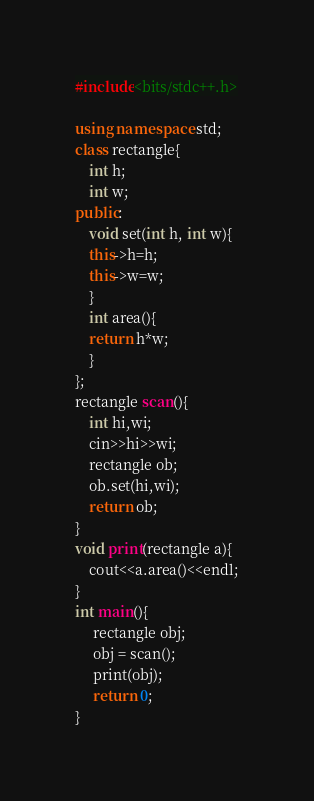<code> <loc_0><loc_0><loc_500><loc_500><_C++_>#include<bits/stdc++.h>

using namespace std;
class rectangle{
    int h;
    int w;
public:
    void set(int h, int w){
    this->h=h;
    this->w=w;
    }
    int area(){
    return h*w;
    }
};
rectangle scan(){
    int hi,wi;
    cin>>hi>>wi;
    rectangle ob;
    ob.set(hi,wi);
    return ob;
}
void print(rectangle a){
    cout<<a.area()<<endl;
}
int main(){
     rectangle obj;
     obj = scan();
     print(obj);
     return 0;
}
</code> 